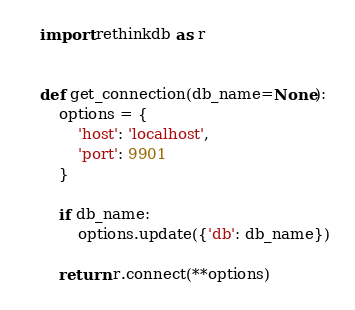<code> <loc_0><loc_0><loc_500><loc_500><_Python_>import rethinkdb as r


def get_connection(db_name=None):
    options = {
        'host': 'localhost',
        'port': 9901
    }

    if db_name:
        options.update({'db': db_name})

    return r.connect(**options)
</code> 